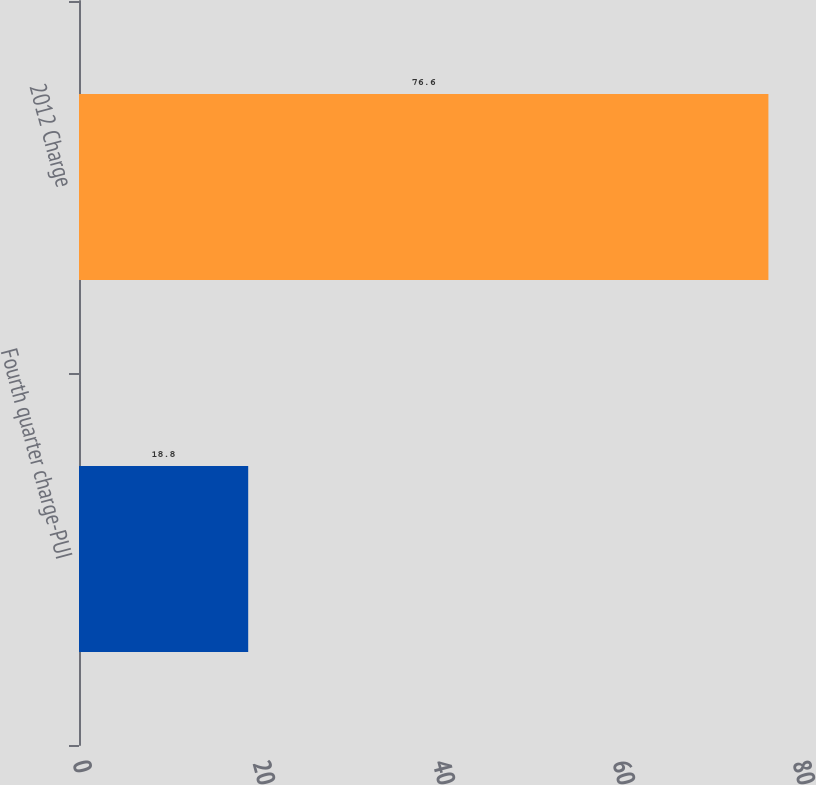<chart> <loc_0><loc_0><loc_500><loc_500><bar_chart><fcel>Fourth quarter charge-PUI<fcel>2012 Charge<nl><fcel>18.8<fcel>76.6<nl></chart> 